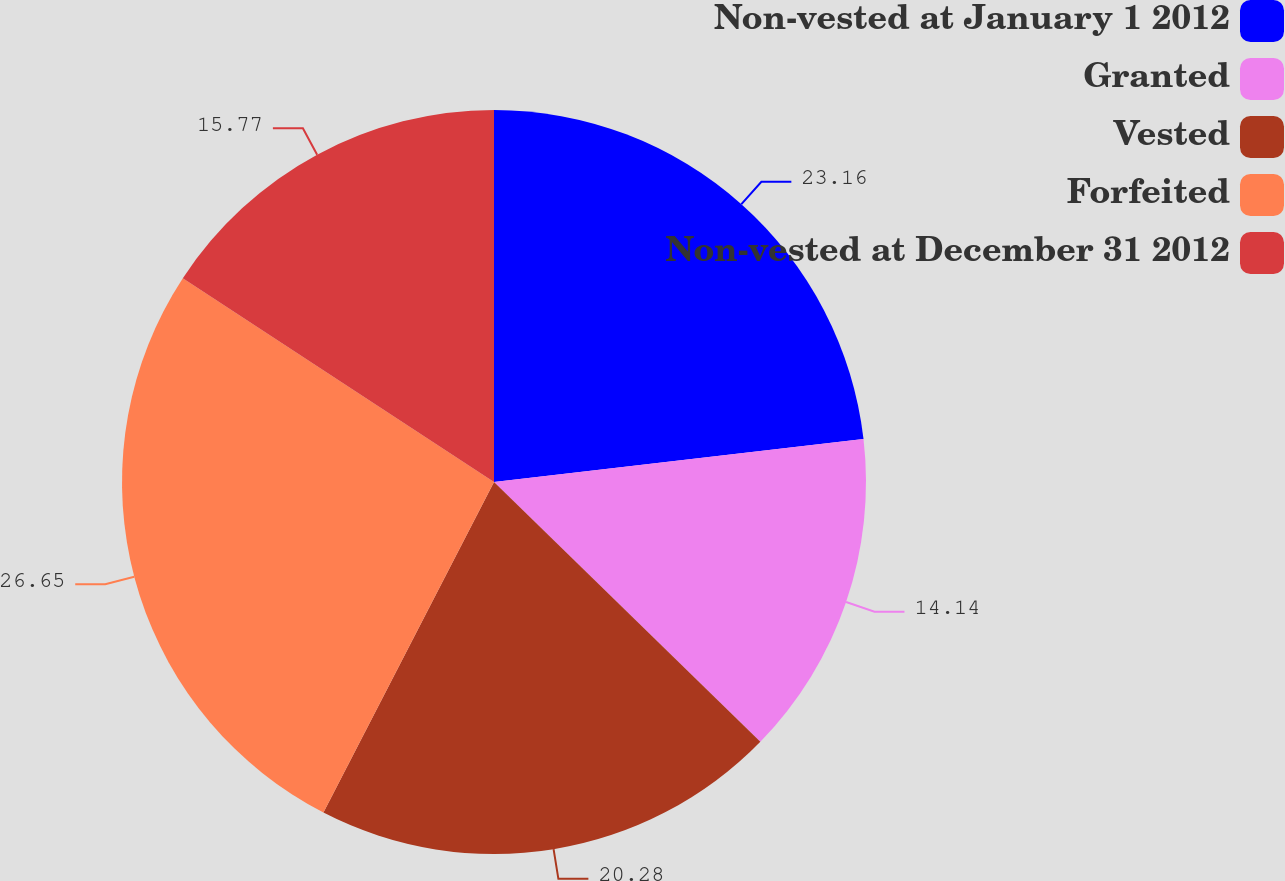Convert chart to OTSL. <chart><loc_0><loc_0><loc_500><loc_500><pie_chart><fcel>Non-vested at January 1 2012<fcel>Granted<fcel>Vested<fcel>Forfeited<fcel>Non-vested at December 31 2012<nl><fcel>23.16%<fcel>14.14%<fcel>20.28%<fcel>26.65%<fcel>15.77%<nl></chart> 